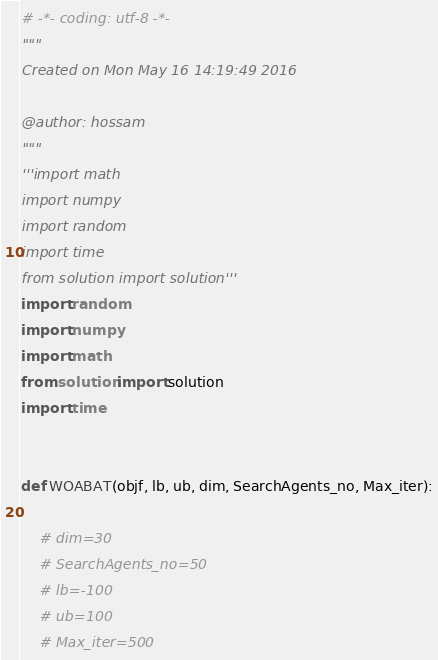<code> <loc_0><loc_0><loc_500><loc_500><_Python_># -*- coding: utf-8 -*-
"""
Created on Mon May 16 14:19:49 2016

@author: hossam
"""
'''import math
import numpy
import random
import time
from solution import solution'''
import random
import numpy
import math
from solution import solution
import time


def WOABAT(objf, lb, ub, dim, SearchAgents_no, Max_iter):

    # dim=30
    # SearchAgents_no=50
    # lb=-100
    # ub=100
    # Max_iter=500</code> 